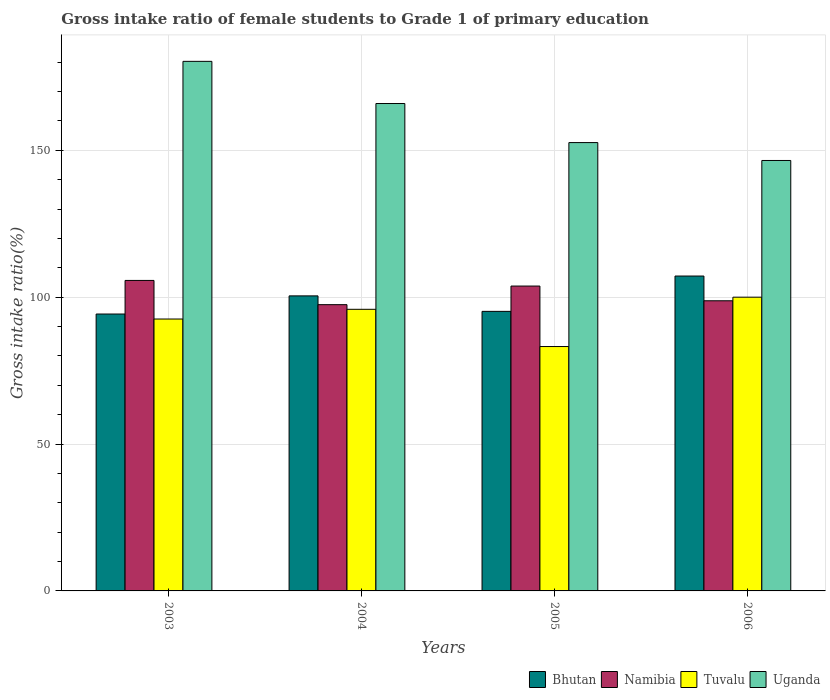Are the number of bars on each tick of the X-axis equal?
Your answer should be very brief. Yes. How many bars are there on the 1st tick from the right?
Give a very brief answer. 4. In how many cases, is the number of bars for a given year not equal to the number of legend labels?
Your answer should be compact. 0. What is the gross intake ratio in Uganda in 2003?
Provide a succinct answer. 180.28. Across all years, what is the maximum gross intake ratio in Uganda?
Keep it short and to the point. 180.28. Across all years, what is the minimum gross intake ratio in Namibia?
Give a very brief answer. 97.45. What is the total gross intake ratio in Namibia in the graph?
Ensure brevity in your answer.  405.7. What is the difference between the gross intake ratio in Namibia in 2003 and that in 2004?
Your response must be concise. 8.25. What is the difference between the gross intake ratio in Uganda in 2005 and the gross intake ratio in Bhutan in 2003?
Keep it short and to the point. 58.37. What is the average gross intake ratio in Bhutan per year?
Provide a succinct answer. 99.27. In the year 2005, what is the difference between the gross intake ratio in Uganda and gross intake ratio in Bhutan?
Your answer should be compact. 57.46. What is the ratio of the gross intake ratio in Tuvalu in 2004 to that in 2005?
Provide a short and direct response. 1.15. Is the difference between the gross intake ratio in Uganda in 2003 and 2006 greater than the difference between the gross intake ratio in Bhutan in 2003 and 2006?
Your response must be concise. Yes. What is the difference between the highest and the second highest gross intake ratio in Tuvalu?
Your response must be concise. 4.13. What is the difference between the highest and the lowest gross intake ratio in Bhutan?
Your response must be concise. 12.93. Is the sum of the gross intake ratio in Uganda in 2003 and 2006 greater than the maximum gross intake ratio in Tuvalu across all years?
Provide a short and direct response. Yes. Is it the case that in every year, the sum of the gross intake ratio in Uganda and gross intake ratio in Tuvalu is greater than the sum of gross intake ratio in Namibia and gross intake ratio in Bhutan?
Your response must be concise. Yes. What does the 4th bar from the left in 2003 represents?
Provide a succinct answer. Uganda. What does the 2nd bar from the right in 2003 represents?
Make the answer very short. Tuvalu. How many bars are there?
Your response must be concise. 16. How many years are there in the graph?
Your answer should be very brief. 4. Are the values on the major ticks of Y-axis written in scientific E-notation?
Your answer should be compact. No. Does the graph contain grids?
Offer a terse response. Yes. What is the title of the graph?
Provide a short and direct response. Gross intake ratio of female students to Grade 1 of primary education. What is the label or title of the Y-axis?
Your answer should be very brief. Gross intake ratio(%). What is the Gross intake ratio(%) of Bhutan in 2003?
Your answer should be very brief. 94.26. What is the Gross intake ratio(%) of Namibia in 2003?
Give a very brief answer. 105.7. What is the Gross intake ratio(%) in Tuvalu in 2003?
Make the answer very short. 92.56. What is the Gross intake ratio(%) in Uganda in 2003?
Your response must be concise. 180.28. What is the Gross intake ratio(%) in Bhutan in 2004?
Ensure brevity in your answer.  100.44. What is the Gross intake ratio(%) in Namibia in 2004?
Give a very brief answer. 97.45. What is the Gross intake ratio(%) in Tuvalu in 2004?
Your answer should be very brief. 95.87. What is the Gross intake ratio(%) in Uganda in 2004?
Give a very brief answer. 165.92. What is the Gross intake ratio(%) of Bhutan in 2005?
Your answer should be very brief. 95.17. What is the Gross intake ratio(%) of Namibia in 2005?
Make the answer very short. 103.78. What is the Gross intake ratio(%) of Tuvalu in 2005?
Provide a short and direct response. 83.19. What is the Gross intake ratio(%) in Uganda in 2005?
Make the answer very short. 152.63. What is the Gross intake ratio(%) in Bhutan in 2006?
Ensure brevity in your answer.  107.19. What is the Gross intake ratio(%) of Namibia in 2006?
Give a very brief answer. 98.77. What is the Gross intake ratio(%) of Uganda in 2006?
Ensure brevity in your answer.  146.53. Across all years, what is the maximum Gross intake ratio(%) in Bhutan?
Provide a succinct answer. 107.19. Across all years, what is the maximum Gross intake ratio(%) in Namibia?
Your response must be concise. 105.7. Across all years, what is the maximum Gross intake ratio(%) of Tuvalu?
Give a very brief answer. 100. Across all years, what is the maximum Gross intake ratio(%) of Uganda?
Your answer should be compact. 180.28. Across all years, what is the minimum Gross intake ratio(%) in Bhutan?
Your answer should be very brief. 94.26. Across all years, what is the minimum Gross intake ratio(%) in Namibia?
Provide a short and direct response. 97.45. Across all years, what is the minimum Gross intake ratio(%) of Tuvalu?
Your response must be concise. 83.19. Across all years, what is the minimum Gross intake ratio(%) in Uganda?
Make the answer very short. 146.53. What is the total Gross intake ratio(%) in Bhutan in the graph?
Make the answer very short. 397.07. What is the total Gross intake ratio(%) of Namibia in the graph?
Your response must be concise. 405.7. What is the total Gross intake ratio(%) of Tuvalu in the graph?
Make the answer very short. 371.62. What is the total Gross intake ratio(%) of Uganda in the graph?
Your answer should be compact. 645.36. What is the difference between the Gross intake ratio(%) in Bhutan in 2003 and that in 2004?
Provide a short and direct response. -6.18. What is the difference between the Gross intake ratio(%) in Namibia in 2003 and that in 2004?
Your response must be concise. 8.25. What is the difference between the Gross intake ratio(%) of Tuvalu in 2003 and that in 2004?
Provide a short and direct response. -3.31. What is the difference between the Gross intake ratio(%) of Uganda in 2003 and that in 2004?
Keep it short and to the point. 14.36. What is the difference between the Gross intake ratio(%) in Bhutan in 2003 and that in 2005?
Keep it short and to the point. -0.91. What is the difference between the Gross intake ratio(%) in Namibia in 2003 and that in 2005?
Offer a terse response. 1.92. What is the difference between the Gross intake ratio(%) in Tuvalu in 2003 and that in 2005?
Your answer should be compact. 9.37. What is the difference between the Gross intake ratio(%) of Uganda in 2003 and that in 2005?
Ensure brevity in your answer.  27.65. What is the difference between the Gross intake ratio(%) in Bhutan in 2003 and that in 2006?
Provide a succinct answer. -12.93. What is the difference between the Gross intake ratio(%) in Namibia in 2003 and that in 2006?
Give a very brief answer. 6.93. What is the difference between the Gross intake ratio(%) of Tuvalu in 2003 and that in 2006?
Ensure brevity in your answer.  -7.44. What is the difference between the Gross intake ratio(%) of Uganda in 2003 and that in 2006?
Offer a terse response. 33.75. What is the difference between the Gross intake ratio(%) of Bhutan in 2004 and that in 2005?
Your answer should be compact. 5.27. What is the difference between the Gross intake ratio(%) in Namibia in 2004 and that in 2005?
Give a very brief answer. -6.34. What is the difference between the Gross intake ratio(%) in Tuvalu in 2004 and that in 2005?
Your answer should be compact. 12.67. What is the difference between the Gross intake ratio(%) of Uganda in 2004 and that in 2005?
Ensure brevity in your answer.  13.29. What is the difference between the Gross intake ratio(%) in Bhutan in 2004 and that in 2006?
Offer a very short reply. -6.75. What is the difference between the Gross intake ratio(%) in Namibia in 2004 and that in 2006?
Offer a terse response. -1.33. What is the difference between the Gross intake ratio(%) of Tuvalu in 2004 and that in 2006?
Provide a short and direct response. -4.13. What is the difference between the Gross intake ratio(%) of Uganda in 2004 and that in 2006?
Your answer should be very brief. 19.39. What is the difference between the Gross intake ratio(%) in Bhutan in 2005 and that in 2006?
Ensure brevity in your answer.  -12.02. What is the difference between the Gross intake ratio(%) of Namibia in 2005 and that in 2006?
Offer a terse response. 5.01. What is the difference between the Gross intake ratio(%) in Tuvalu in 2005 and that in 2006?
Your answer should be very brief. -16.81. What is the difference between the Gross intake ratio(%) in Uganda in 2005 and that in 2006?
Ensure brevity in your answer.  6.09. What is the difference between the Gross intake ratio(%) of Bhutan in 2003 and the Gross intake ratio(%) of Namibia in 2004?
Ensure brevity in your answer.  -3.19. What is the difference between the Gross intake ratio(%) in Bhutan in 2003 and the Gross intake ratio(%) in Tuvalu in 2004?
Give a very brief answer. -1.61. What is the difference between the Gross intake ratio(%) of Bhutan in 2003 and the Gross intake ratio(%) of Uganda in 2004?
Your answer should be very brief. -71.66. What is the difference between the Gross intake ratio(%) in Namibia in 2003 and the Gross intake ratio(%) in Tuvalu in 2004?
Offer a very short reply. 9.83. What is the difference between the Gross intake ratio(%) in Namibia in 2003 and the Gross intake ratio(%) in Uganda in 2004?
Provide a succinct answer. -60.22. What is the difference between the Gross intake ratio(%) in Tuvalu in 2003 and the Gross intake ratio(%) in Uganda in 2004?
Your response must be concise. -73.36. What is the difference between the Gross intake ratio(%) in Bhutan in 2003 and the Gross intake ratio(%) in Namibia in 2005?
Keep it short and to the point. -9.52. What is the difference between the Gross intake ratio(%) of Bhutan in 2003 and the Gross intake ratio(%) of Tuvalu in 2005?
Your answer should be very brief. 11.07. What is the difference between the Gross intake ratio(%) of Bhutan in 2003 and the Gross intake ratio(%) of Uganda in 2005?
Keep it short and to the point. -58.37. What is the difference between the Gross intake ratio(%) of Namibia in 2003 and the Gross intake ratio(%) of Tuvalu in 2005?
Ensure brevity in your answer.  22.51. What is the difference between the Gross intake ratio(%) of Namibia in 2003 and the Gross intake ratio(%) of Uganda in 2005?
Offer a very short reply. -46.93. What is the difference between the Gross intake ratio(%) of Tuvalu in 2003 and the Gross intake ratio(%) of Uganda in 2005?
Make the answer very short. -60.07. What is the difference between the Gross intake ratio(%) in Bhutan in 2003 and the Gross intake ratio(%) in Namibia in 2006?
Your response must be concise. -4.51. What is the difference between the Gross intake ratio(%) in Bhutan in 2003 and the Gross intake ratio(%) in Tuvalu in 2006?
Provide a short and direct response. -5.74. What is the difference between the Gross intake ratio(%) in Bhutan in 2003 and the Gross intake ratio(%) in Uganda in 2006?
Offer a terse response. -52.27. What is the difference between the Gross intake ratio(%) of Namibia in 2003 and the Gross intake ratio(%) of Tuvalu in 2006?
Give a very brief answer. 5.7. What is the difference between the Gross intake ratio(%) of Namibia in 2003 and the Gross intake ratio(%) of Uganda in 2006?
Provide a short and direct response. -40.83. What is the difference between the Gross intake ratio(%) in Tuvalu in 2003 and the Gross intake ratio(%) in Uganda in 2006?
Offer a terse response. -53.97. What is the difference between the Gross intake ratio(%) in Bhutan in 2004 and the Gross intake ratio(%) in Namibia in 2005?
Make the answer very short. -3.34. What is the difference between the Gross intake ratio(%) in Bhutan in 2004 and the Gross intake ratio(%) in Tuvalu in 2005?
Provide a succinct answer. 17.25. What is the difference between the Gross intake ratio(%) in Bhutan in 2004 and the Gross intake ratio(%) in Uganda in 2005?
Your response must be concise. -52.19. What is the difference between the Gross intake ratio(%) in Namibia in 2004 and the Gross intake ratio(%) in Tuvalu in 2005?
Give a very brief answer. 14.26. What is the difference between the Gross intake ratio(%) of Namibia in 2004 and the Gross intake ratio(%) of Uganda in 2005?
Keep it short and to the point. -55.18. What is the difference between the Gross intake ratio(%) in Tuvalu in 2004 and the Gross intake ratio(%) in Uganda in 2005?
Offer a very short reply. -56.76. What is the difference between the Gross intake ratio(%) of Bhutan in 2004 and the Gross intake ratio(%) of Namibia in 2006?
Ensure brevity in your answer.  1.67. What is the difference between the Gross intake ratio(%) in Bhutan in 2004 and the Gross intake ratio(%) in Tuvalu in 2006?
Provide a short and direct response. 0.44. What is the difference between the Gross intake ratio(%) in Bhutan in 2004 and the Gross intake ratio(%) in Uganda in 2006?
Your answer should be very brief. -46.09. What is the difference between the Gross intake ratio(%) in Namibia in 2004 and the Gross intake ratio(%) in Tuvalu in 2006?
Your answer should be compact. -2.55. What is the difference between the Gross intake ratio(%) of Namibia in 2004 and the Gross intake ratio(%) of Uganda in 2006?
Make the answer very short. -49.09. What is the difference between the Gross intake ratio(%) of Tuvalu in 2004 and the Gross intake ratio(%) of Uganda in 2006?
Make the answer very short. -50.67. What is the difference between the Gross intake ratio(%) of Bhutan in 2005 and the Gross intake ratio(%) of Namibia in 2006?
Offer a terse response. -3.6. What is the difference between the Gross intake ratio(%) of Bhutan in 2005 and the Gross intake ratio(%) of Tuvalu in 2006?
Your answer should be compact. -4.83. What is the difference between the Gross intake ratio(%) of Bhutan in 2005 and the Gross intake ratio(%) of Uganda in 2006?
Offer a terse response. -51.36. What is the difference between the Gross intake ratio(%) of Namibia in 2005 and the Gross intake ratio(%) of Tuvalu in 2006?
Make the answer very short. 3.78. What is the difference between the Gross intake ratio(%) in Namibia in 2005 and the Gross intake ratio(%) in Uganda in 2006?
Your response must be concise. -42.75. What is the difference between the Gross intake ratio(%) in Tuvalu in 2005 and the Gross intake ratio(%) in Uganda in 2006?
Ensure brevity in your answer.  -63.34. What is the average Gross intake ratio(%) of Bhutan per year?
Provide a short and direct response. 99.27. What is the average Gross intake ratio(%) of Namibia per year?
Your answer should be compact. 101.43. What is the average Gross intake ratio(%) of Tuvalu per year?
Ensure brevity in your answer.  92.91. What is the average Gross intake ratio(%) in Uganda per year?
Your answer should be compact. 161.34. In the year 2003, what is the difference between the Gross intake ratio(%) of Bhutan and Gross intake ratio(%) of Namibia?
Keep it short and to the point. -11.44. In the year 2003, what is the difference between the Gross intake ratio(%) of Bhutan and Gross intake ratio(%) of Tuvalu?
Provide a short and direct response. 1.7. In the year 2003, what is the difference between the Gross intake ratio(%) of Bhutan and Gross intake ratio(%) of Uganda?
Offer a terse response. -86.02. In the year 2003, what is the difference between the Gross intake ratio(%) of Namibia and Gross intake ratio(%) of Tuvalu?
Provide a succinct answer. 13.14. In the year 2003, what is the difference between the Gross intake ratio(%) of Namibia and Gross intake ratio(%) of Uganda?
Your answer should be very brief. -74.58. In the year 2003, what is the difference between the Gross intake ratio(%) in Tuvalu and Gross intake ratio(%) in Uganda?
Provide a succinct answer. -87.72. In the year 2004, what is the difference between the Gross intake ratio(%) in Bhutan and Gross intake ratio(%) in Namibia?
Offer a terse response. 2.99. In the year 2004, what is the difference between the Gross intake ratio(%) in Bhutan and Gross intake ratio(%) in Tuvalu?
Offer a terse response. 4.57. In the year 2004, what is the difference between the Gross intake ratio(%) in Bhutan and Gross intake ratio(%) in Uganda?
Provide a short and direct response. -65.48. In the year 2004, what is the difference between the Gross intake ratio(%) in Namibia and Gross intake ratio(%) in Tuvalu?
Ensure brevity in your answer.  1.58. In the year 2004, what is the difference between the Gross intake ratio(%) of Namibia and Gross intake ratio(%) of Uganda?
Provide a short and direct response. -68.47. In the year 2004, what is the difference between the Gross intake ratio(%) in Tuvalu and Gross intake ratio(%) in Uganda?
Your answer should be very brief. -70.05. In the year 2005, what is the difference between the Gross intake ratio(%) in Bhutan and Gross intake ratio(%) in Namibia?
Provide a short and direct response. -8.61. In the year 2005, what is the difference between the Gross intake ratio(%) of Bhutan and Gross intake ratio(%) of Tuvalu?
Keep it short and to the point. 11.98. In the year 2005, what is the difference between the Gross intake ratio(%) in Bhutan and Gross intake ratio(%) in Uganda?
Provide a succinct answer. -57.46. In the year 2005, what is the difference between the Gross intake ratio(%) of Namibia and Gross intake ratio(%) of Tuvalu?
Give a very brief answer. 20.59. In the year 2005, what is the difference between the Gross intake ratio(%) in Namibia and Gross intake ratio(%) in Uganda?
Offer a very short reply. -48.84. In the year 2005, what is the difference between the Gross intake ratio(%) of Tuvalu and Gross intake ratio(%) of Uganda?
Your answer should be compact. -69.44. In the year 2006, what is the difference between the Gross intake ratio(%) of Bhutan and Gross intake ratio(%) of Namibia?
Offer a terse response. 8.42. In the year 2006, what is the difference between the Gross intake ratio(%) in Bhutan and Gross intake ratio(%) in Tuvalu?
Make the answer very short. 7.19. In the year 2006, what is the difference between the Gross intake ratio(%) of Bhutan and Gross intake ratio(%) of Uganda?
Provide a succinct answer. -39.34. In the year 2006, what is the difference between the Gross intake ratio(%) of Namibia and Gross intake ratio(%) of Tuvalu?
Ensure brevity in your answer.  -1.23. In the year 2006, what is the difference between the Gross intake ratio(%) of Namibia and Gross intake ratio(%) of Uganda?
Keep it short and to the point. -47.76. In the year 2006, what is the difference between the Gross intake ratio(%) of Tuvalu and Gross intake ratio(%) of Uganda?
Make the answer very short. -46.53. What is the ratio of the Gross intake ratio(%) in Bhutan in 2003 to that in 2004?
Ensure brevity in your answer.  0.94. What is the ratio of the Gross intake ratio(%) of Namibia in 2003 to that in 2004?
Your answer should be very brief. 1.08. What is the ratio of the Gross intake ratio(%) in Tuvalu in 2003 to that in 2004?
Your answer should be compact. 0.97. What is the ratio of the Gross intake ratio(%) of Uganda in 2003 to that in 2004?
Ensure brevity in your answer.  1.09. What is the ratio of the Gross intake ratio(%) of Namibia in 2003 to that in 2005?
Offer a very short reply. 1.02. What is the ratio of the Gross intake ratio(%) in Tuvalu in 2003 to that in 2005?
Keep it short and to the point. 1.11. What is the ratio of the Gross intake ratio(%) of Uganda in 2003 to that in 2005?
Keep it short and to the point. 1.18. What is the ratio of the Gross intake ratio(%) of Bhutan in 2003 to that in 2006?
Ensure brevity in your answer.  0.88. What is the ratio of the Gross intake ratio(%) in Namibia in 2003 to that in 2006?
Offer a terse response. 1.07. What is the ratio of the Gross intake ratio(%) in Tuvalu in 2003 to that in 2006?
Give a very brief answer. 0.93. What is the ratio of the Gross intake ratio(%) of Uganda in 2003 to that in 2006?
Your answer should be very brief. 1.23. What is the ratio of the Gross intake ratio(%) in Bhutan in 2004 to that in 2005?
Provide a short and direct response. 1.06. What is the ratio of the Gross intake ratio(%) in Namibia in 2004 to that in 2005?
Your answer should be very brief. 0.94. What is the ratio of the Gross intake ratio(%) in Tuvalu in 2004 to that in 2005?
Keep it short and to the point. 1.15. What is the ratio of the Gross intake ratio(%) of Uganda in 2004 to that in 2005?
Provide a short and direct response. 1.09. What is the ratio of the Gross intake ratio(%) in Bhutan in 2004 to that in 2006?
Offer a terse response. 0.94. What is the ratio of the Gross intake ratio(%) of Namibia in 2004 to that in 2006?
Provide a short and direct response. 0.99. What is the ratio of the Gross intake ratio(%) in Tuvalu in 2004 to that in 2006?
Provide a succinct answer. 0.96. What is the ratio of the Gross intake ratio(%) in Uganda in 2004 to that in 2006?
Offer a terse response. 1.13. What is the ratio of the Gross intake ratio(%) of Bhutan in 2005 to that in 2006?
Ensure brevity in your answer.  0.89. What is the ratio of the Gross intake ratio(%) of Namibia in 2005 to that in 2006?
Provide a short and direct response. 1.05. What is the ratio of the Gross intake ratio(%) of Tuvalu in 2005 to that in 2006?
Give a very brief answer. 0.83. What is the ratio of the Gross intake ratio(%) of Uganda in 2005 to that in 2006?
Your response must be concise. 1.04. What is the difference between the highest and the second highest Gross intake ratio(%) in Bhutan?
Give a very brief answer. 6.75. What is the difference between the highest and the second highest Gross intake ratio(%) of Namibia?
Your response must be concise. 1.92. What is the difference between the highest and the second highest Gross intake ratio(%) in Tuvalu?
Offer a very short reply. 4.13. What is the difference between the highest and the second highest Gross intake ratio(%) in Uganda?
Make the answer very short. 14.36. What is the difference between the highest and the lowest Gross intake ratio(%) in Bhutan?
Make the answer very short. 12.93. What is the difference between the highest and the lowest Gross intake ratio(%) in Namibia?
Make the answer very short. 8.25. What is the difference between the highest and the lowest Gross intake ratio(%) of Tuvalu?
Make the answer very short. 16.81. What is the difference between the highest and the lowest Gross intake ratio(%) of Uganda?
Ensure brevity in your answer.  33.75. 